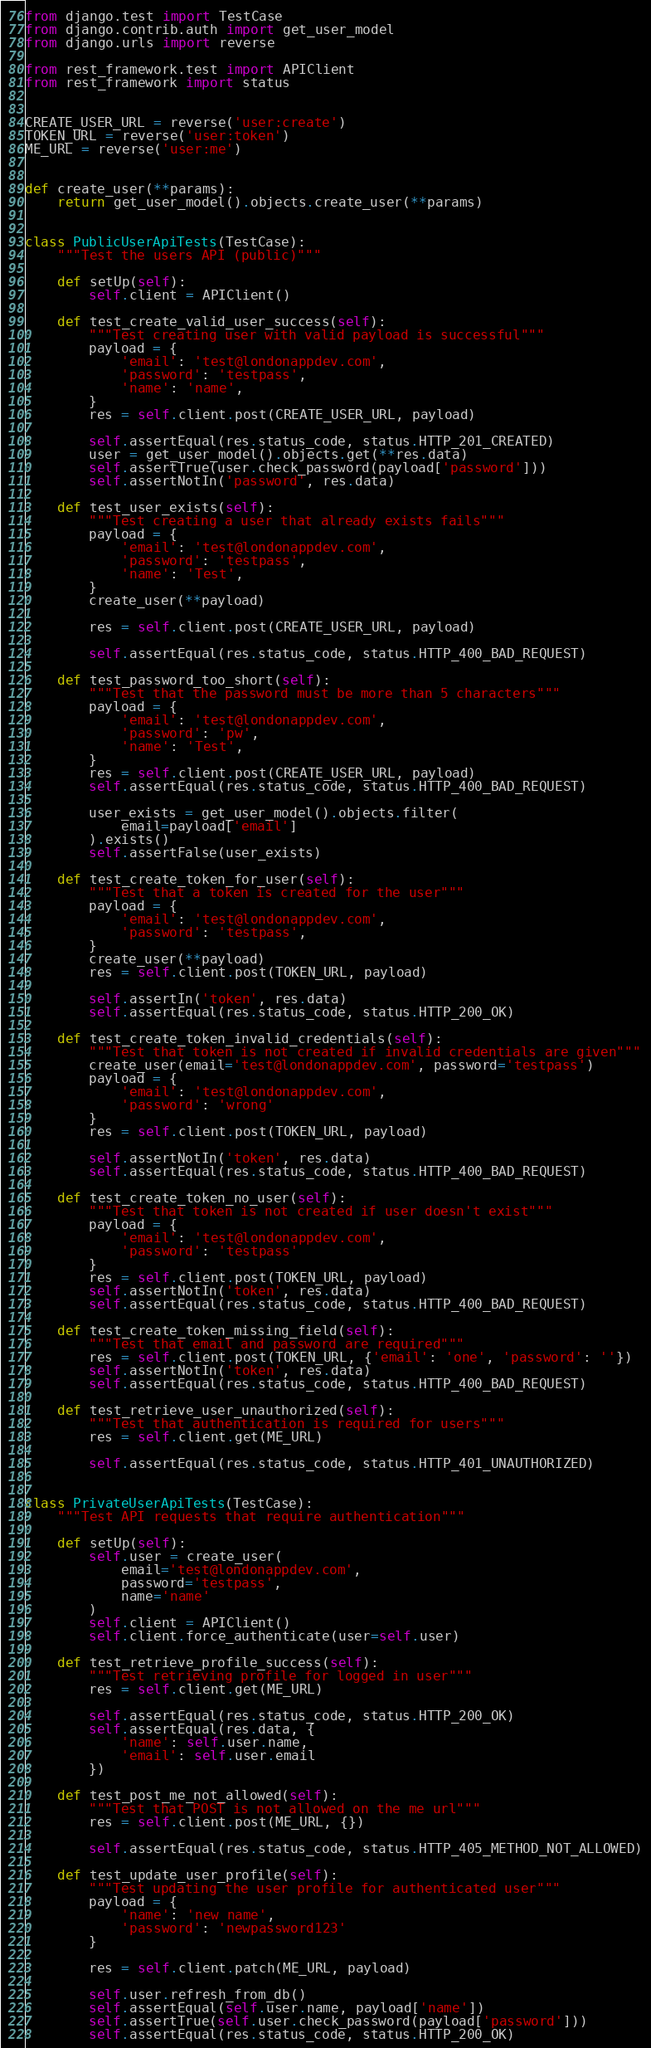<code> <loc_0><loc_0><loc_500><loc_500><_Python_>from django.test import TestCase
from django.contrib.auth import get_user_model
from django.urls import reverse

from rest_framework.test import APIClient
from rest_framework import status


CREATE_USER_URL = reverse('user:create')
TOKEN_URL = reverse('user:token')
ME_URL = reverse('user:me')


def create_user(**params):
    return get_user_model().objects.create_user(**params)


class PublicUserApiTests(TestCase):
    """Test the users API (public)"""

    def setUp(self):
        self.client = APIClient()

    def test_create_valid_user_success(self):
        """Test creating user with valid payload is successful"""
        payload = {
            'email': 'test@londonappdev.com',
            'password': 'testpass',
            'name': 'name',
        }
        res = self.client.post(CREATE_USER_URL, payload)

        self.assertEqual(res.status_code, status.HTTP_201_CREATED)
        user = get_user_model().objects.get(**res.data)
        self.assertTrue(user.check_password(payload['password']))
        self.assertNotIn('password', res.data)

    def test_user_exists(self):
        """Test creating a user that already exists fails"""
        payload = {
            'email': 'test@londonappdev.com',
            'password': 'testpass',
            'name': 'Test',
        }
        create_user(**payload)

        res = self.client.post(CREATE_USER_URL, payload)

        self.assertEqual(res.status_code, status.HTTP_400_BAD_REQUEST)

    def test_password_too_short(self):
        """Test that the password must be more than 5 characters"""
        payload = {
            'email': 'test@londonappdev.com',
            'password': 'pw',
            'name': 'Test',
        }
        res = self.client.post(CREATE_USER_URL, payload)
        self.assertEqual(res.status_code, status.HTTP_400_BAD_REQUEST)

        user_exists = get_user_model().objects.filter(
            email=payload['email']
        ).exists()
        self.assertFalse(user_exists)

    def test_create_token_for_user(self):
        """Test that a token is created for the user"""
        payload = {
            'email': 'test@londonappdev.com',
            'password': 'testpass',
        }
        create_user(**payload)
        res = self.client.post(TOKEN_URL, payload)

        self.assertIn('token', res.data)
        self.assertEqual(res.status_code, status.HTTP_200_OK)

    def test_create_token_invalid_credentials(self):
        """Test that token is not created if invalid credentials are given"""
        create_user(email='test@londonappdev.com', password='testpass')
        payload = {
            'email': 'test@londonappdev.com',
            'password': 'wrong'
        }
        res = self.client.post(TOKEN_URL, payload)

        self.assertNotIn('token', res.data)
        self.assertEqual(res.status_code, status.HTTP_400_BAD_REQUEST)

    def test_create_token_no_user(self):
        """Test that token is not created if user doesn't exist"""
        payload = {
            'email': 'test@londonappdev.com',
            'password': 'testpass'
        }
        res = self.client.post(TOKEN_URL, payload)
        self.assertNotIn('token', res.data)
        self.assertEqual(res.status_code, status.HTTP_400_BAD_REQUEST)

    def test_create_token_missing_field(self):
        """Test that email and password are required"""
        res = self.client.post(TOKEN_URL, {'email': 'one', 'password': ''})
        self.assertNotIn('token', res.data)
        self.assertEqual(res.status_code, status.HTTP_400_BAD_REQUEST)

    def test_retrieve_user_unauthorized(self):
        """Test that authentication is required for users"""
        res = self.client.get(ME_URL)

        self.assertEqual(res.status_code, status.HTTP_401_UNAUTHORIZED)


class PrivateUserApiTests(TestCase):
    """Test API requests that require authentication"""

    def setUp(self):
        self.user = create_user(
            email='test@londonappdev.com',
            password='testpass',
            name='name'
        )
        self.client = APIClient()
        self.client.force_authenticate(user=self.user)

    def test_retrieve_profile_success(self):
        """Test retrieving profile for logged in user"""
        res = self.client.get(ME_URL)

        self.assertEqual(res.status_code, status.HTTP_200_OK)
        self.assertEqual(res.data, {
            'name': self.user.name,
            'email': self.user.email
        })

    def test_post_me_not_allowed(self):
        """Test that POST is not allowed on the me url"""
        res = self.client.post(ME_URL, {})

        self.assertEqual(res.status_code, status.HTTP_405_METHOD_NOT_ALLOWED)

    def test_update_user_profile(self):
        """Test updating the user profile for authenticated user"""
        payload = {
            'name': 'new name',
            'password': 'newpassword123'
        }

        res = self.client.patch(ME_URL, payload)

        self.user.refresh_from_db()
        self.assertEqual(self.user.name, payload['name'])
        self.assertTrue(self.user.check_password(payload['password']))
        self.assertEqual(res.status_code, status.HTTP_200_OK)
</code> 